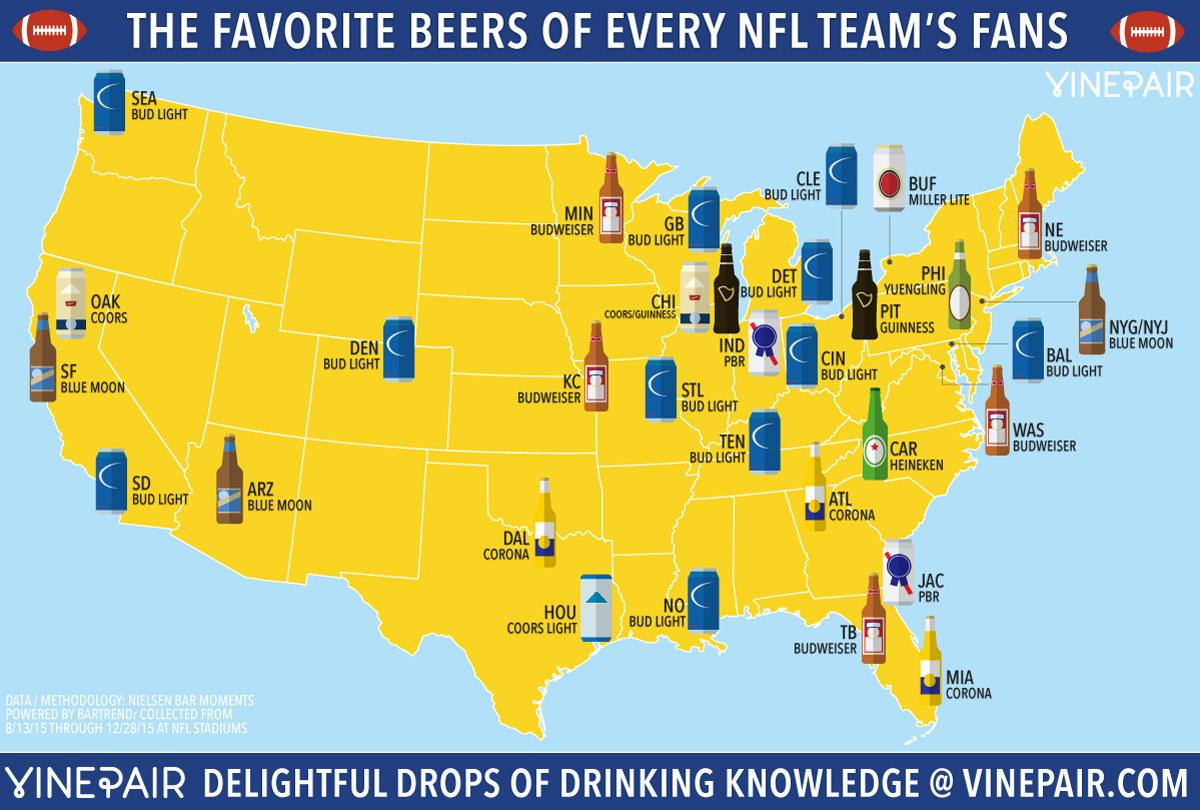Mention a couple of crucial points in this snapshot. Out of all the fans of teams, it was found that 3% prefer Corona as their favorite beer. According to the infographic, Budweiser is the second-most preferred brand of beer among NFL team fans. Budweiser is the favorite brand of fans of five NFL teams. A significant number of fans of NFL teams prefer to drink Bud Light. It is reported that one team's fans enjoy drinking Heineken beer. 